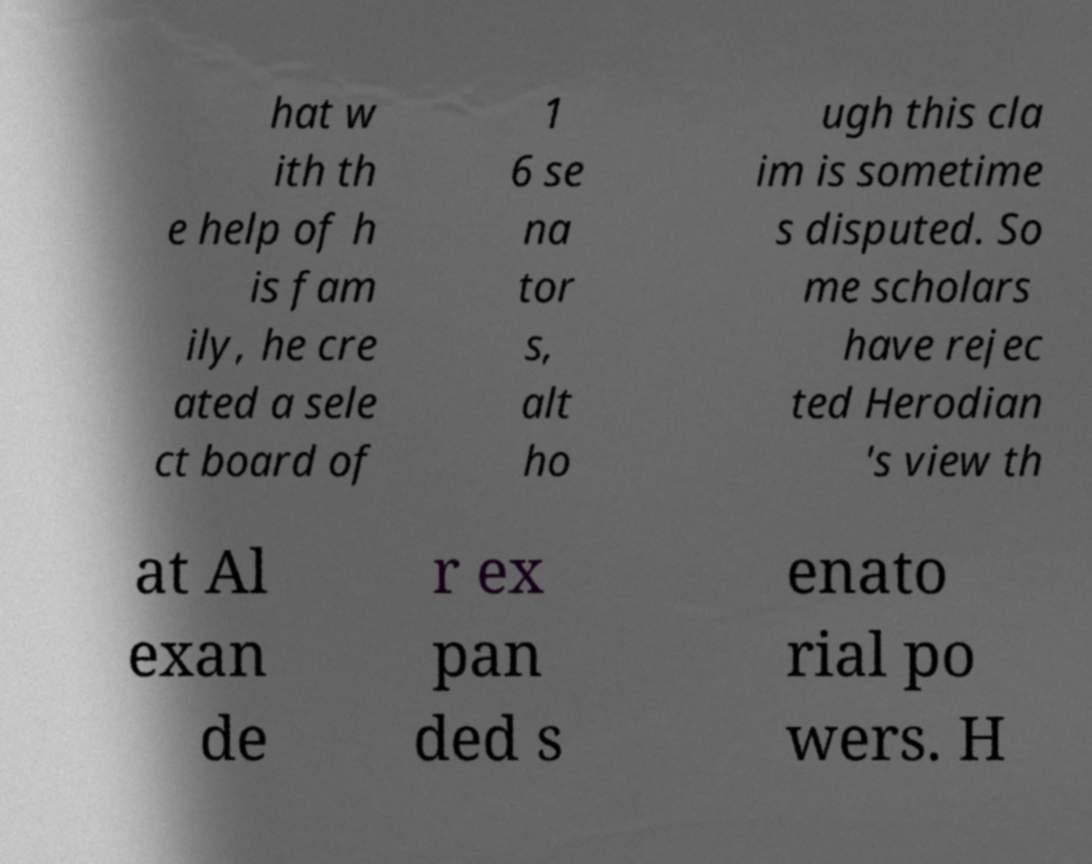There's text embedded in this image that I need extracted. Can you transcribe it verbatim? hat w ith th e help of h is fam ily, he cre ated a sele ct board of 1 6 se na tor s, alt ho ugh this cla im is sometime s disputed. So me scholars have rejec ted Herodian 's view th at Al exan de r ex pan ded s enato rial po wers. H 